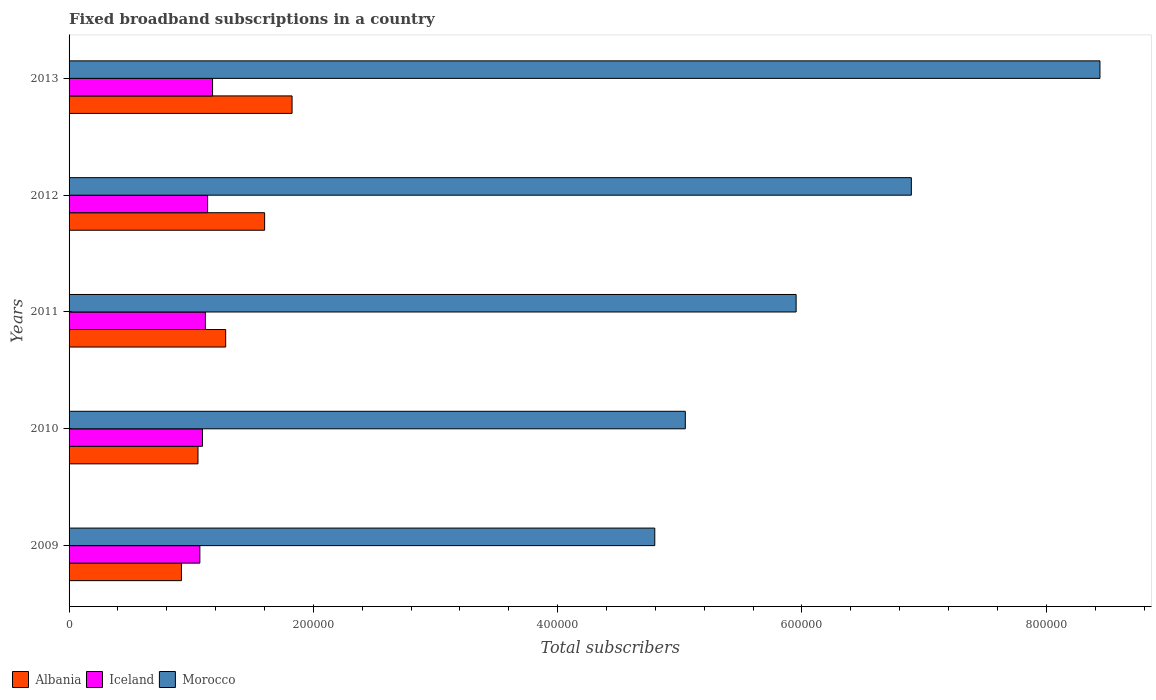How many different coloured bars are there?
Ensure brevity in your answer.  3. Are the number of bars on each tick of the Y-axis equal?
Offer a terse response. Yes. How many bars are there on the 5th tick from the top?
Your answer should be very brief. 3. What is the number of broadband subscriptions in Iceland in 2009?
Your answer should be very brief. 1.07e+05. Across all years, what is the maximum number of broadband subscriptions in Morocco?
Your answer should be very brief. 8.44e+05. Across all years, what is the minimum number of broadband subscriptions in Iceland?
Make the answer very short. 1.07e+05. In which year was the number of broadband subscriptions in Morocco maximum?
Give a very brief answer. 2013. In which year was the number of broadband subscriptions in Albania minimum?
Offer a very short reply. 2009. What is the total number of broadband subscriptions in Morocco in the graph?
Your response must be concise. 3.11e+06. What is the difference between the number of broadband subscriptions in Morocco in 2009 and that in 2012?
Your response must be concise. -2.10e+05. What is the difference between the number of broadband subscriptions in Iceland in 2009 and the number of broadband subscriptions in Morocco in 2013?
Provide a succinct answer. -7.37e+05. What is the average number of broadband subscriptions in Iceland per year?
Your answer should be very brief. 1.12e+05. In the year 2012, what is the difference between the number of broadband subscriptions in Morocco and number of broadband subscriptions in Albania?
Ensure brevity in your answer.  5.29e+05. What is the ratio of the number of broadband subscriptions in Iceland in 2010 to that in 2011?
Give a very brief answer. 0.98. What is the difference between the highest and the second highest number of broadband subscriptions in Morocco?
Your answer should be compact. 1.54e+05. What is the difference between the highest and the lowest number of broadband subscriptions in Morocco?
Offer a very short reply. 3.64e+05. What does the 3rd bar from the top in 2012 represents?
Keep it short and to the point. Albania. What does the 1st bar from the bottom in 2011 represents?
Your answer should be compact. Albania. How many bars are there?
Provide a short and direct response. 15. Does the graph contain any zero values?
Provide a short and direct response. No. Does the graph contain grids?
Provide a succinct answer. No. Where does the legend appear in the graph?
Provide a succinct answer. Bottom left. How are the legend labels stacked?
Provide a succinct answer. Horizontal. What is the title of the graph?
Ensure brevity in your answer.  Fixed broadband subscriptions in a country. Does "High income: nonOECD" appear as one of the legend labels in the graph?
Offer a very short reply. No. What is the label or title of the X-axis?
Give a very brief answer. Total subscribers. What is the Total subscribers of Albania in 2009?
Offer a very short reply. 9.20e+04. What is the Total subscribers in Iceland in 2009?
Keep it short and to the point. 1.07e+05. What is the Total subscribers in Morocco in 2009?
Your answer should be compact. 4.80e+05. What is the Total subscribers of Albania in 2010?
Your response must be concise. 1.06e+05. What is the Total subscribers in Iceland in 2010?
Ensure brevity in your answer.  1.09e+05. What is the Total subscribers in Morocco in 2010?
Your answer should be very brief. 5.04e+05. What is the Total subscribers in Albania in 2011?
Offer a very short reply. 1.28e+05. What is the Total subscribers of Iceland in 2011?
Offer a terse response. 1.12e+05. What is the Total subscribers in Morocco in 2011?
Provide a succinct answer. 5.95e+05. What is the Total subscribers of Albania in 2012?
Keep it short and to the point. 1.60e+05. What is the Total subscribers in Iceland in 2012?
Ensure brevity in your answer.  1.13e+05. What is the Total subscribers in Morocco in 2012?
Your answer should be compact. 6.90e+05. What is the Total subscribers in Albania in 2013?
Keep it short and to the point. 1.83e+05. What is the Total subscribers of Iceland in 2013?
Ensure brevity in your answer.  1.17e+05. What is the Total subscribers of Morocco in 2013?
Give a very brief answer. 8.44e+05. Across all years, what is the maximum Total subscribers in Albania?
Keep it short and to the point. 1.83e+05. Across all years, what is the maximum Total subscribers of Iceland?
Your answer should be compact. 1.17e+05. Across all years, what is the maximum Total subscribers in Morocco?
Your answer should be compact. 8.44e+05. Across all years, what is the minimum Total subscribers in Albania?
Keep it short and to the point. 9.20e+04. Across all years, what is the minimum Total subscribers in Iceland?
Ensure brevity in your answer.  1.07e+05. Across all years, what is the minimum Total subscribers in Morocco?
Your answer should be very brief. 4.80e+05. What is the total Total subscribers in Albania in the graph?
Your answer should be very brief. 6.68e+05. What is the total Total subscribers in Iceland in the graph?
Your answer should be compact. 5.59e+05. What is the total Total subscribers in Morocco in the graph?
Offer a very short reply. 3.11e+06. What is the difference between the Total subscribers of Albania in 2009 and that in 2010?
Provide a succinct answer. -1.35e+04. What is the difference between the Total subscribers in Iceland in 2009 and that in 2010?
Provide a succinct answer. -2140. What is the difference between the Total subscribers in Morocco in 2009 and that in 2010?
Offer a very short reply. -2.50e+04. What is the difference between the Total subscribers of Albania in 2009 and that in 2011?
Provide a succinct answer. -3.62e+04. What is the difference between the Total subscribers in Iceland in 2009 and that in 2011?
Give a very brief answer. -4512. What is the difference between the Total subscribers of Morocco in 2009 and that in 2011?
Ensure brevity in your answer.  -1.16e+05. What is the difference between the Total subscribers of Albania in 2009 and that in 2012?
Offer a very short reply. -6.81e+04. What is the difference between the Total subscribers of Iceland in 2009 and that in 2012?
Offer a very short reply. -6348. What is the difference between the Total subscribers in Morocco in 2009 and that in 2012?
Ensure brevity in your answer.  -2.10e+05. What is the difference between the Total subscribers of Albania in 2009 and that in 2013?
Keep it short and to the point. -9.06e+04. What is the difference between the Total subscribers in Iceland in 2009 and that in 2013?
Your response must be concise. -1.04e+04. What is the difference between the Total subscribers of Morocco in 2009 and that in 2013?
Your answer should be compact. -3.64e+05. What is the difference between the Total subscribers of Albania in 2010 and that in 2011?
Give a very brief answer. -2.27e+04. What is the difference between the Total subscribers in Iceland in 2010 and that in 2011?
Your answer should be very brief. -2372. What is the difference between the Total subscribers of Morocco in 2010 and that in 2011?
Offer a terse response. -9.07e+04. What is the difference between the Total subscribers of Albania in 2010 and that in 2012?
Keep it short and to the point. -5.45e+04. What is the difference between the Total subscribers in Iceland in 2010 and that in 2012?
Your answer should be very brief. -4208. What is the difference between the Total subscribers in Morocco in 2010 and that in 2012?
Keep it short and to the point. -1.85e+05. What is the difference between the Total subscribers of Albania in 2010 and that in 2013?
Provide a short and direct response. -7.70e+04. What is the difference between the Total subscribers of Iceland in 2010 and that in 2013?
Your answer should be very brief. -8255. What is the difference between the Total subscribers in Morocco in 2010 and that in 2013?
Your answer should be very brief. -3.39e+05. What is the difference between the Total subscribers of Albania in 2011 and that in 2012?
Give a very brief answer. -3.19e+04. What is the difference between the Total subscribers of Iceland in 2011 and that in 2012?
Offer a very short reply. -1836. What is the difference between the Total subscribers in Morocco in 2011 and that in 2012?
Provide a succinct answer. -9.43e+04. What is the difference between the Total subscribers of Albania in 2011 and that in 2013?
Make the answer very short. -5.43e+04. What is the difference between the Total subscribers in Iceland in 2011 and that in 2013?
Give a very brief answer. -5883. What is the difference between the Total subscribers in Morocco in 2011 and that in 2013?
Provide a short and direct response. -2.49e+05. What is the difference between the Total subscribers of Albania in 2012 and that in 2013?
Your response must be concise. -2.25e+04. What is the difference between the Total subscribers of Iceland in 2012 and that in 2013?
Offer a terse response. -4047. What is the difference between the Total subscribers in Morocco in 2012 and that in 2013?
Offer a terse response. -1.54e+05. What is the difference between the Total subscribers in Albania in 2009 and the Total subscribers in Iceland in 2010?
Provide a succinct answer. -1.72e+04. What is the difference between the Total subscribers of Albania in 2009 and the Total subscribers of Morocco in 2010?
Your response must be concise. -4.12e+05. What is the difference between the Total subscribers in Iceland in 2009 and the Total subscribers in Morocco in 2010?
Offer a very short reply. -3.97e+05. What is the difference between the Total subscribers of Albania in 2009 and the Total subscribers of Iceland in 2011?
Your answer should be very brief. -1.96e+04. What is the difference between the Total subscribers in Albania in 2009 and the Total subscribers in Morocco in 2011?
Offer a very short reply. -5.03e+05. What is the difference between the Total subscribers of Iceland in 2009 and the Total subscribers of Morocco in 2011?
Provide a succinct answer. -4.88e+05. What is the difference between the Total subscribers in Albania in 2009 and the Total subscribers in Iceland in 2012?
Offer a terse response. -2.14e+04. What is the difference between the Total subscribers in Albania in 2009 and the Total subscribers in Morocco in 2012?
Provide a succinct answer. -5.98e+05. What is the difference between the Total subscribers of Iceland in 2009 and the Total subscribers of Morocco in 2012?
Offer a very short reply. -5.82e+05. What is the difference between the Total subscribers in Albania in 2009 and the Total subscribers in Iceland in 2013?
Make the answer very short. -2.55e+04. What is the difference between the Total subscribers in Albania in 2009 and the Total subscribers in Morocco in 2013?
Make the answer very short. -7.52e+05. What is the difference between the Total subscribers in Iceland in 2009 and the Total subscribers in Morocco in 2013?
Ensure brevity in your answer.  -7.37e+05. What is the difference between the Total subscribers in Albania in 2010 and the Total subscribers in Iceland in 2011?
Provide a short and direct response. -6045. What is the difference between the Total subscribers in Albania in 2010 and the Total subscribers in Morocco in 2011?
Provide a short and direct response. -4.90e+05. What is the difference between the Total subscribers of Iceland in 2010 and the Total subscribers of Morocco in 2011?
Provide a short and direct response. -4.86e+05. What is the difference between the Total subscribers of Albania in 2010 and the Total subscribers of Iceland in 2012?
Provide a succinct answer. -7881. What is the difference between the Total subscribers of Albania in 2010 and the Total subscribers of Morocco in 2012?
Your answer should be compact. -5.84e+05. What is the difference between the Total subscribers in Iceland in 2010 and the Total subscribers in Morocco in 2012?
Your response must be concise. -5.80e+05. What is the difference between the Total subscribers of Albania in 2010 and the Total subscribers of Iceland in 2013?
Make the answer very short. -1.19e+04. What is the difference between the Total subscribers of Albania in 2010 and the Total subscribers of Morocco in 2013?
Your response must be concise. -7.38e+05. What is the difference between the Total subscribers in Iceland in 2010 and the Total subscribers in Morocco in 2013?
Ensure brevity in your answer.  -7.35e+05. What is the difference between the Total subscribers of Albania in 2011 and the Total subscribers of Iceland in 2012?
Make the answer very short. 1.48e+04. What is the difference between the Total subscribers of Albania in 2011 and the Total subscribers of Morocco in 2012?
Provide a short and direct response. -5.61e+05. What is the difference between the Total subscribers of Iceland in 2011 and the Total subscribers of Morocco in 2012?
Your answer should be very brief. -5.78e+05. What is the difference between the Total subscribers of Albania in 2011 and the Total subscribers of Iceland in 2013?
Offer a terse response. 1.07e+04. What is the difference between the Total subscribers of Albania in 2011 and the Total subscribers of Morocco in 2013?
Offer a terse response. -7.16e+05. What is the difference between the Total subscribers in Iceland in 2011 and the Total subscribers in Morocco in 2013?
Provide a short and direct response. -7.32e+05. What is the difference between the Total subscribers of Albania in 2012 and the Total subscribers of Iceland in 2013?
Ensure brevity in your answer.  4.26e+04. What is the difference between the Total subscribers of Albania in 2012 and the Total subscribers of Morocco in 2013?
Your response must be concise. -6.84e+05. What is the difference between the Total subscribers in Iceland in 2012 and the Total subscribers in Morocco in 2013?
Make the answer very short. -7.31e+05. What is the average Total subscribers of Albania per year?
Your answer should be compact. 1.34e+05. What is the average Total subscribers of Iceland per year?
Your answer should be compact. 1.12e+05. What is the average Total subscribers in Morocco per year?
Provide a short and direct response. 6.23e+05. In the year 2009, what is the difference between the Total subscribers of Albania and Total subscribers of Iceland?
Provide a succinct answer. -1.51e+04. In the year 2009, what is the difference between the Total subscribers of Albania and Total subscribers of Morocco?
Your answer should be very brief. -3.88e+05. In the year 2009, what is the difference between the Total subscribers in Iceland and Total subscribers in Morocco?
Offer a terse response. -3.72e+05. In the year 2010, what is the difference between the Total subscribers in Albania and Total subscribers in Iceland?
Give a very brief answer. -3673. In the year 2010, what is the difference between the Total subscribers in Albania and Total subscribers in Morocco?
Offer a very short reply. -3.99e+05. In the year 2010, what is the difference between the Total subscribers in Iceland and Total subscribers in Morocco?
Your answer should be compact. -3.95e+05. In the year 2011, what is the difference between the Total subscribers of Albania and Total subscribers of Iceland?
Ensure brevity in your answer.  1.66e+04. In the year 2011, what is the difference between the Total subscribers of Albania and Total subscribers of Morocco?
Ensure brevity in your answer.  -4.67e+05. In the year 2011, what is the difference between the Total subscribers in Iceland and Total subscribers in Morocco?
Keep it short and to the point. -4.84e+05. In the year 2012, what is the difference between the Total subscribers of Albania and Total subscribers of Iceland?
Offer a very short reply. 4.67e+04. In the year 2012, what is the difference between the Total subscribers of Albania and Total subscribers of Morocco?
Ensure brevity in your answer.  -5.29e+05. In the year 2012, what is the difference between the Total subscribers of Iceland and Total subscribers of Morocco?
Provide a short and direct response. -5.76e+05. In the year 2013, what is the difference between the Total subscribers of Albania and Total subscribers of Iceland?
Your response must be concise. 6.51e+04. In the year 2013, what is the difference between the Total subscribers of Albania and Total subscribers of Morocco?
Provide a short and direct response. -6.61e+05. In the year 2013, what is the difference between the Total subscribers of Iceland and Total subscribers of Morocco?
Your answer should be very brief. -7.26e+05. What is the ratio of the Total subscribers of Albania in 2009 to that in 2010?
Offer a terse response. 0.87. What is the ratio of the Total subscribers in Iceland in 2009 to that in 2010?
Your answer should be compact. 0.98. What is the ratio of the Total subscribers in Morocco in 2009 to that in 2010?
Your answer should be very brief. 0.95. What is the ratio of the Total subscribers in Albania in 2009 to that in 2011?
Offer a terse response. 0.72. What is the ratio of the Total subscribers of Iceland in 2009 to that in 2011?
Keep it short and to the point. 0.96. What is the ratio of the Total subscribers of Morocco in 2009 to that in 2011?
Ensure brevity in your answer.  0.81. What is the ratio of the Total subscribers of Albania in 2009 to that in 2012?
Your answer should be very brief. 0.57. What is the ratio of the Total subscribers in Iceland in 2009 to that in 2012?
Offer a very short reply. 0.94. What is the ratio of the Total subscribers of Morocco in 2009 to that in 2012?
Provide a succinct answer. 0.7. What is the ratio of the Total subscribers of Albania in 2009 to that in 2013?
Ensure brevity in your answer.  0.5. What is the ratio of the Total subscribers in Iceland in 2009 to that in 2013?
Keep it short and to the point. 0.91. What is the ratio of the Total subscribers of Morocco in 2009 to that in 2013?
Ensure brevity in your answer.  0.57. What is the ratio of the Total subscribers of Albania in 2010 to that in 2011?
Your response must be concise. 0.82. What is the ratio of the Total subscribers in Iceland in 2010 to that in 2011?
Make the answer very short. 0.98. What is the ratio of the Total subscribers of Morocco in 2010 to that in 2011?
Give a very brief answer. 0.85. What is the ratio of the Total subscribers in Albania in 2010 to that in 2012?
Provide a short and direct response. 0.66. What is the ratio of the Total subscribers in Iceland in 2010 to that in 2012?
Provide a short and direct response. 0.96. What is the ratio of the Total subscribers of Morocco in 2010 to that in 2012?
Ensure brevity in your answer.  0.73. What is the ratio of the Total subscribers in Albania in 2010 to that in 2013?
Provide a succinct answer. 0.58. What is the ratio of the Total subscribers of Iceland in 2010 to that in 2013?
Make the answer very short. 0.93. What is the ratio of the Total subscribers in Morocco in 2010 to that in 2013?
Keep it short and to the point. 0.6. What is the ratio of the Total subscribers of Albania in 2011 to that in 2012?
Provide a short and direct response. 0.8. What is the ratio of the Total subscribers in Iceland in 2011 to that in 2012?
Ensure brevity in your answer.  0.98. What is the ratio of the Total subscribers of Morocco in 2011 to that in 2012?
Your answer should be compact. 0.86. What is the ratio of the Total subscribers in Albania in 2011 to that in 2013?
Keep it short and to the point. 0.7. What is the ratio of the Total subscribers of Iceland in 2011 to that in 2013?
Give a very brief answer. 0.95. What is the ratio of the Total subscribers in Morocco in 2011 to that in 2013?
Offer a terse response. 0.71. What is the ratio of the Total subscribers in Albania in 2012 to that in 2013?
Offer a terse response. 0.88. What is the ratio of the Total subscribers in Iceland in 2012 to that in 2013?
Your response must be concise. 0.97. What is the ratio of the Total subscribers of Morocco in 2012 to that in 2013?
Make the answer very short. 0.82. What is the difference between the highest and the second highest Total subscribers in Albania?
Your answer should be compact. 2.25e+04. What is the difference between the highest and the second highest Total subscribers of Iceland?
Offer a terse response. 4047. What is the difference between the highest and the second highest Total subscribers in Morocco?
Provide a short and direct response. 1.54e+05. What is the difference between the highest and the lowest Total subscribers in Albania?
Your answer should be compact. 9.06e+04. What is the difference between the highest and the lowest Total subscribers of Iceland?
Provide a succinct answer. 1.04e+04. What is the difference between the highest and the lowest Total subscribers in Morocco?
Keep it short and to the point. 3.64e+05. 